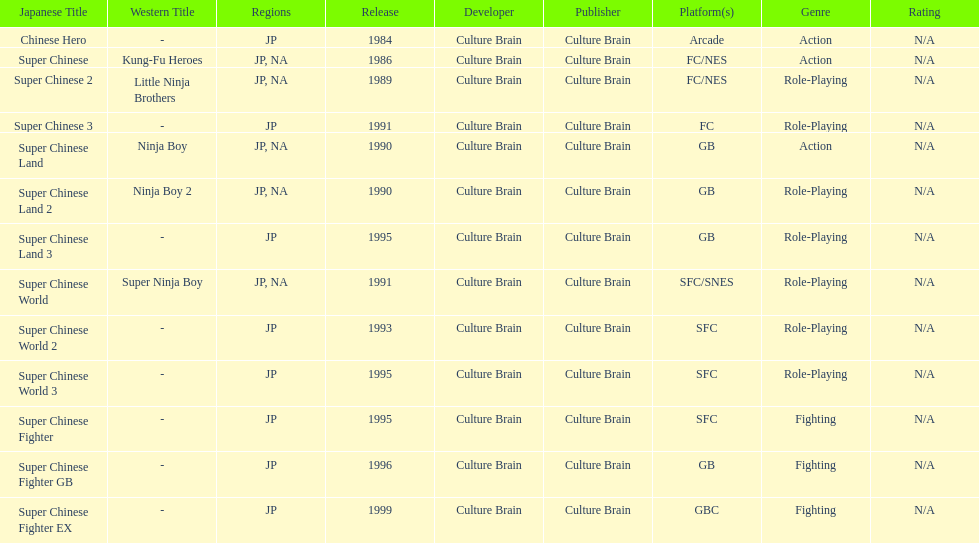Number of super chinese world games released 3. 